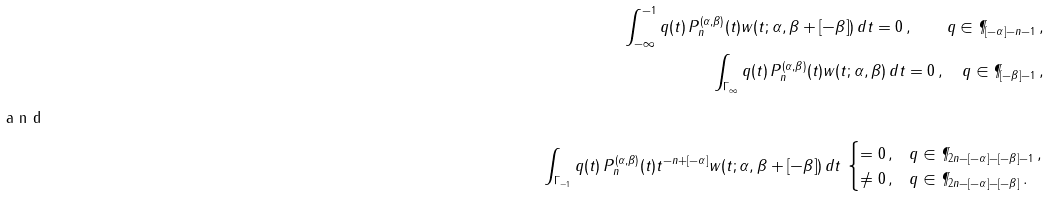Convert formula to latex. <formula><loc_0><loc_0><loc_500><loc_500>\int _ { - \infty } ^ { - 1 } q ( t ) \, P _ { n } ^ { ( \alpha , \beta ) } ( t ) w ( t ; \alpha , \beta + [ - \beta ] ) \, d t = 0 \, , \quad q \in \P _ { [ - \alpha ] - n - 1 } \, , \\ \int _ { \Gamma _ { \infty } } q ( t ) \, P _ { n } ^ { ( \alpha , \beta ) } ( t ) w ( t ; \alpha , \beta ) \, d t = 0 \, , \quad q \in \P _ { [ - \beta ] - 1 } \, , \\ \intertext { a n d } \int _ { \Gamma _ { - 1 } } q ( t ) \, P _ { n } ^ { ( \alpha , \beta ) } ( t ) t ^ { - n + [ - \alpha ] } w ( t ; \alpha , \beta + [ - \beta ] ) \, d t \, \begin{cases} = 0 \, , & q \in \P _ { 2 n - [ - \alpha ] - [ - \beta ] - 1 } \, , \\ \neq 0 \, , & q \in \P _ { 2 n - [ - \alpha ] - [ - \beta ] } \, . \end{cases}</formula> 